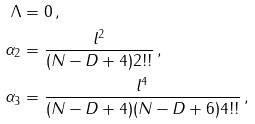Convert formula to latex. <formula><loc_0><loc_0><loc_500><loc_500>\Lambda & = 0 \, , \\ \alpha _ { 2 } & = \frac { l ^ { 2 } } { ( N - D + 4 ) 2 ! ! } \, , \\ \alpha _ { 3 } & = \frac { l ^ { 4 } } { ( N - D + 4 ) ( N - D + 6 ) 4 ! ! } \, ,</formula> 